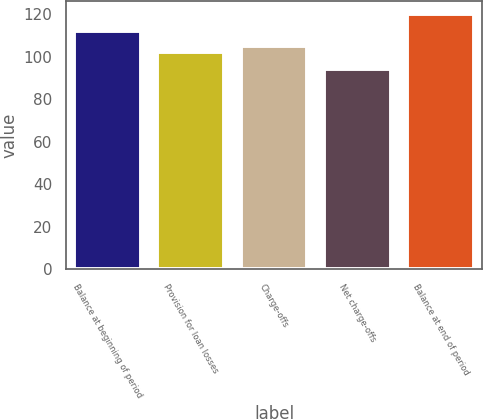Convert chart to OTSL. <chart><loc_0><loc_0><loc_500><loc_500><bar_chart><fcel>Balance at beginning of period<fcel>Provision for loan losses<fcel>Charge-offs<fcel>Net charge-offs<fcel>Balance at end of period<nl><fcel>112<fcel>102<fcel>105<fcel>94<fcel>120<nl></chart> 